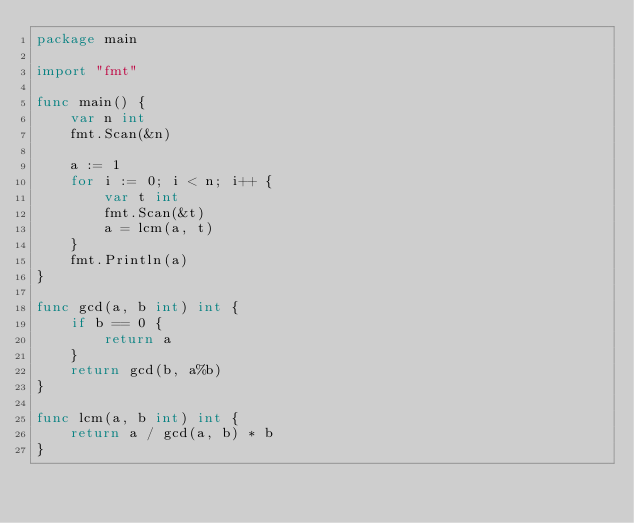Convert code to text. <code><loc_0><loc_0><loc_500><loc_500><_Go_>package main

import "fmt"

func main() {
	var n int
	fmt.Scan(&n)

	a := 1
	for i := 0; i < n; i++ {
		var t int
		fmt.Scan(&t)
		a = lcm(a, t)
	}
	fmt.Println(a)
}

func gcd(a, b int) int {
	if b == 0 {
		return a
	}
	return gcd(b, a%b)
}

func lcm(a, b int) int {
	return a / gcd(a, b) * b
}
</code> 